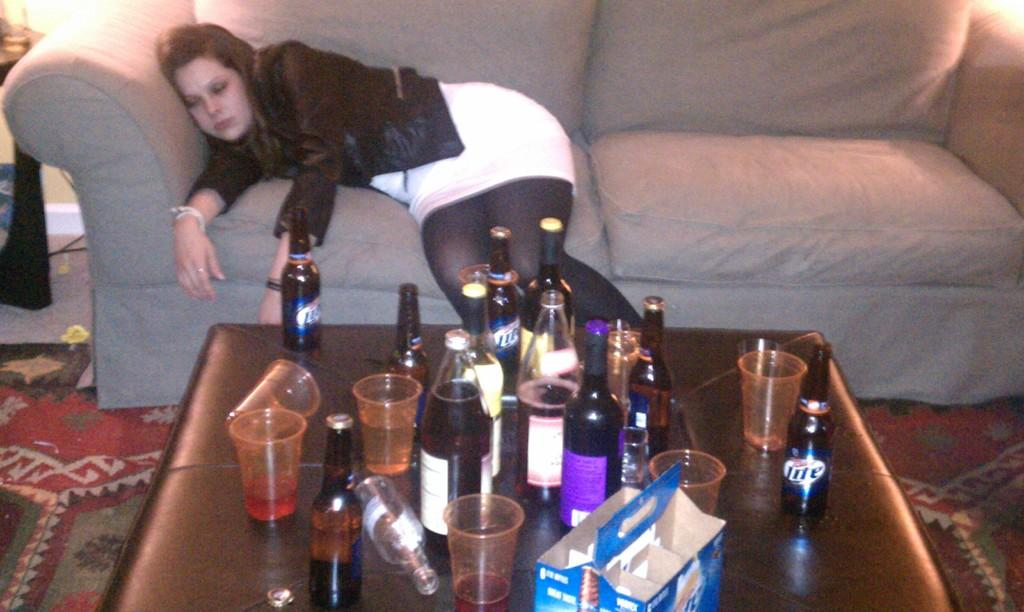What is the woman doing in the image? The woman is laying on a couch in the image. What objects are on the table in the image? There are bottles, glasses, and a box on a table in the image. What type of apparel is the woman wearing in the image? The provided facts do not mention any details about the woman's clothing, so we cannot determine the type of apparel she is wearing. 